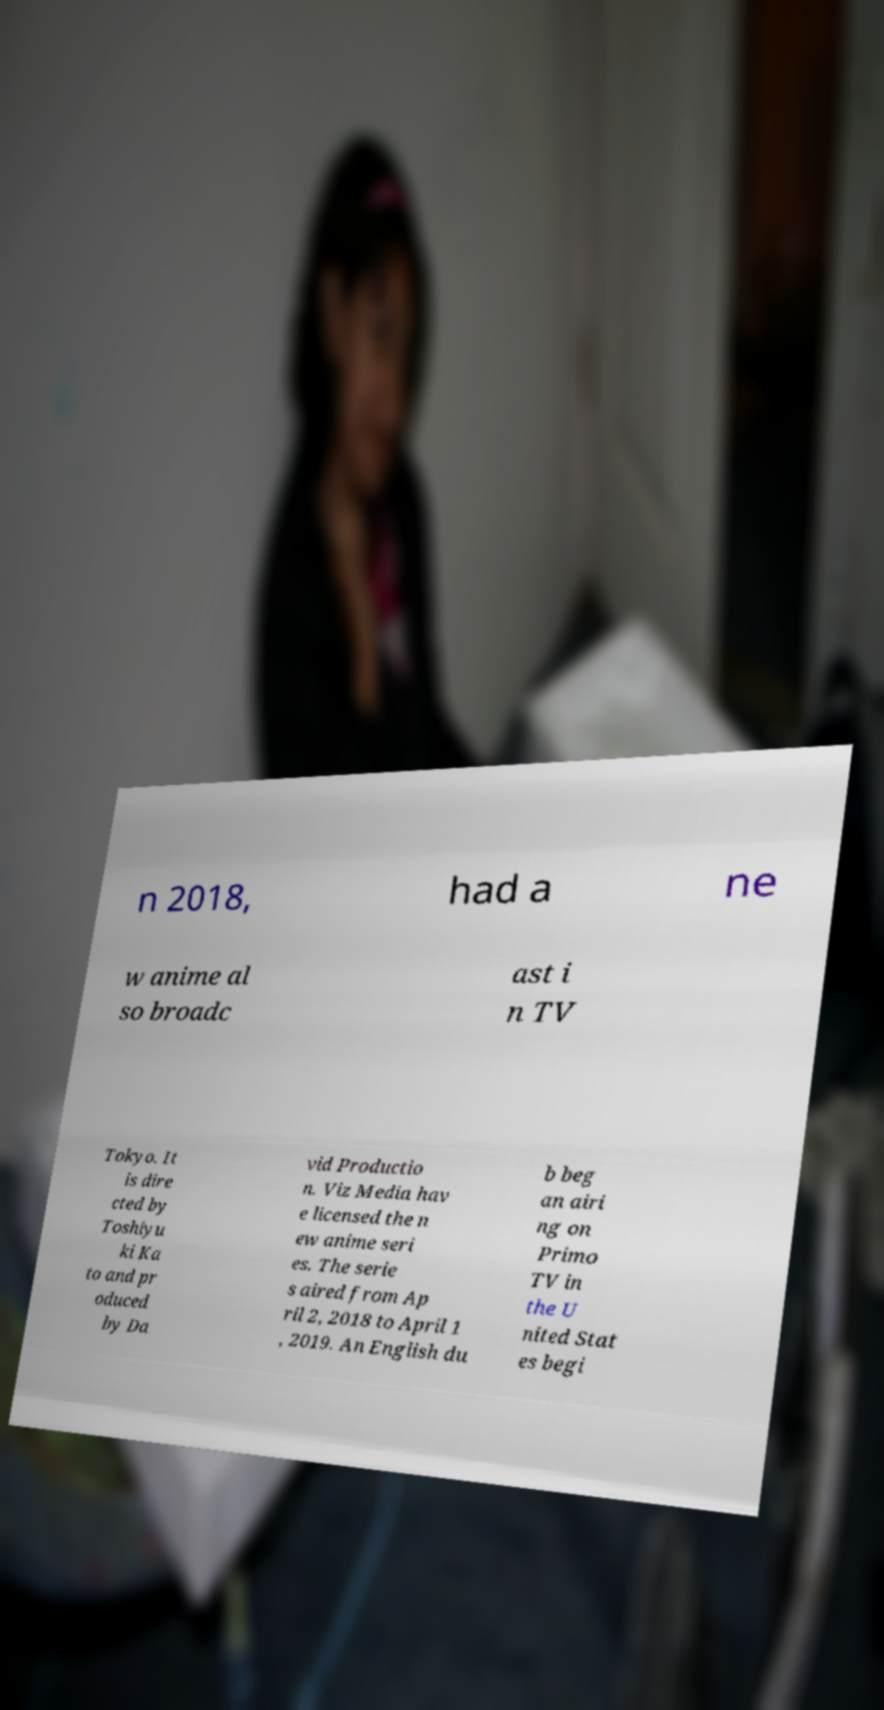Could you assist in decoding the text presented in this image and type it out clearly? n 2018, had a ne w anime al so broadc ast i n TV Tokyo. It is dire cted by Toshiyu ki Ka to and pr oduced by Da vid Productio n. Viz Media hav e licensed the n ew anime seri es. The serie s aired from Ap ril 2, 2018 to April 1 , 2019. An English du b beg an airi ng on Primo TV in the U nited Stat es begi 